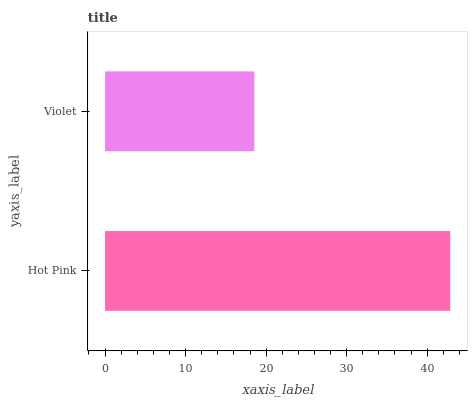Is Violet the minimum?
Answer yes or no. Yes. Is Hot Pink the maximum?
Answer yes or no. Yes. Is Violet the maximum?
Answer yes or no. No. Is Hot Pink greater than Violet?
Answer yes or no. Yes. Is Violet less than Hot Pink?
Answer yes or no. Yes. Is Violet greater than Hot Pink?
Answer yes or no. No. Is Hot Pink less than Violet?
Answer yes or no. No. Is Hot Pink the high median?
Answer yes or no. Yes. Is Violet the low median?
Answer yes or no. Yes. Is Violet the high median?
Answer yes or no. No. Is Hot Pink the low median?
Answer yes or no. No. 